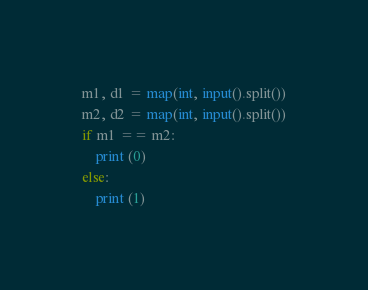<code> <loc_0><loc_0><loc_500><loc_500><_Python_>m1, d1 = map(int, input().split())
m2, d2 = map(int, input().split())
if m1 == m2:
	print (0)
else:
	print (1)</code> 